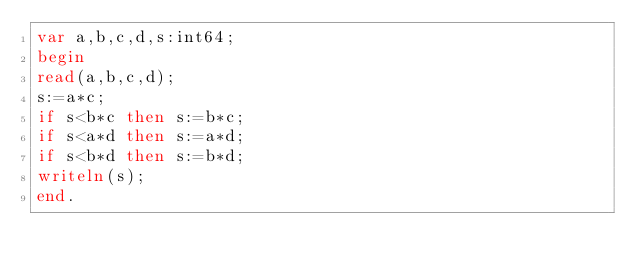<code> <loc_0><loc_0><loc_500><loc_500><_Pascal_>var a,b,c,d,s:int64;
begin
read(a,b,c,d);
s:=a*c;
if s<b*c then s:=b*c;
if s<a*d then s:=a*d;
if s<b*d then s:=b*d;
writeln(s);
end.</code> 